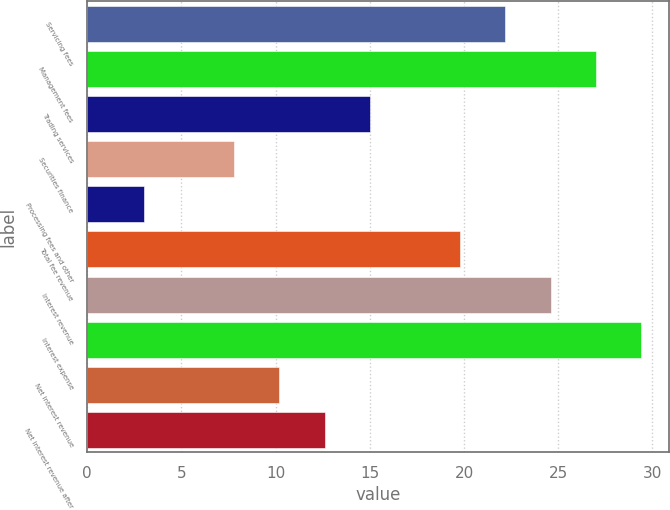Convert chart to OTSL. <chart><loc_0><loc_0><loc_500><loc_500><bar_chart><fcel>Servicing fees<fcel>Management fees<fcel>Trading services<fcel>Securities finance<fcel>Processing fees and other<fcel>Total fee revenue<fcel>Interest revenue<fcel>Interest expense<fcel>Net interest revenue<fcel>Net interest revenue after<nl><fcel>22.2<fcel>27<fcel>15<fcel>7.8<fcel>3<fcel>19.8<fcel>24.6<fcel>29.4<fcel>10.2<fcel>12.6<nl></chart> 